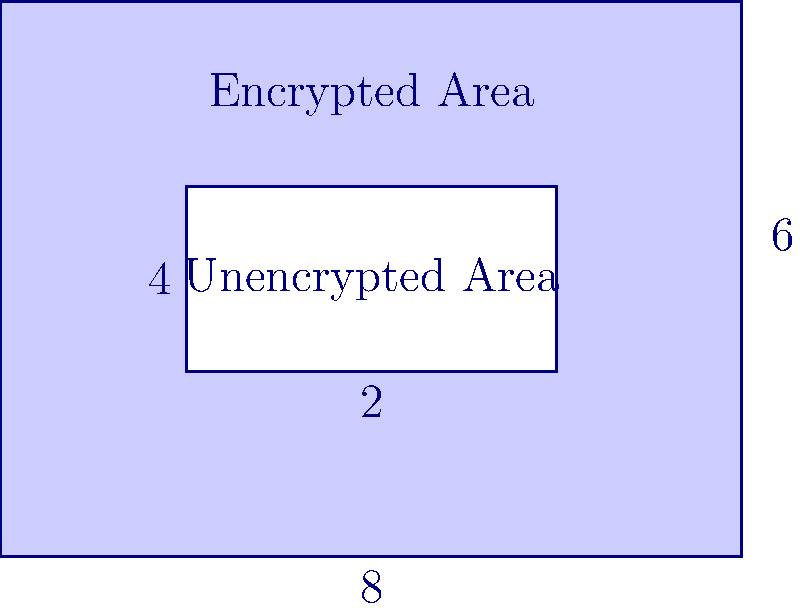A rectangular database storage system measures 8 units wide and 6 units high. Within this system, there's an unencrypted region measuring 4 units wide and 2 units high, centered in the larger rectangle. If the shaded area represents encrypted data, what percentage of the total database is encrypted? To solve this problem, we'll follow these steps:

1. Calculate the total area of the database:
   $A_{total} = 8 \times 6 = 48$ square units

2. Calculate the area of the unencrypted region:
   $A_{unencrypted} = 4 \times 2 = 8$ square units

3. Calculate the encrypted area by subtracting the unencrypted area from the total area:
   $A_{encrypted} = A_{total} - A_{unencrypted} = 48 - 8 = 40$ square units

4. Calculate the percentage of encrypted data:
   $\text{Percentage encrypted} = \frac{A_{encrypted}}{A_{total}} \times 100\%$
   $= \frac{40}{48} \times 100\% = \frac{5}{6} \times 100\% \approx 83.33\%$

Therefore, approximately 83.33% of the total database is encrypted.
Answer: 83.33% 